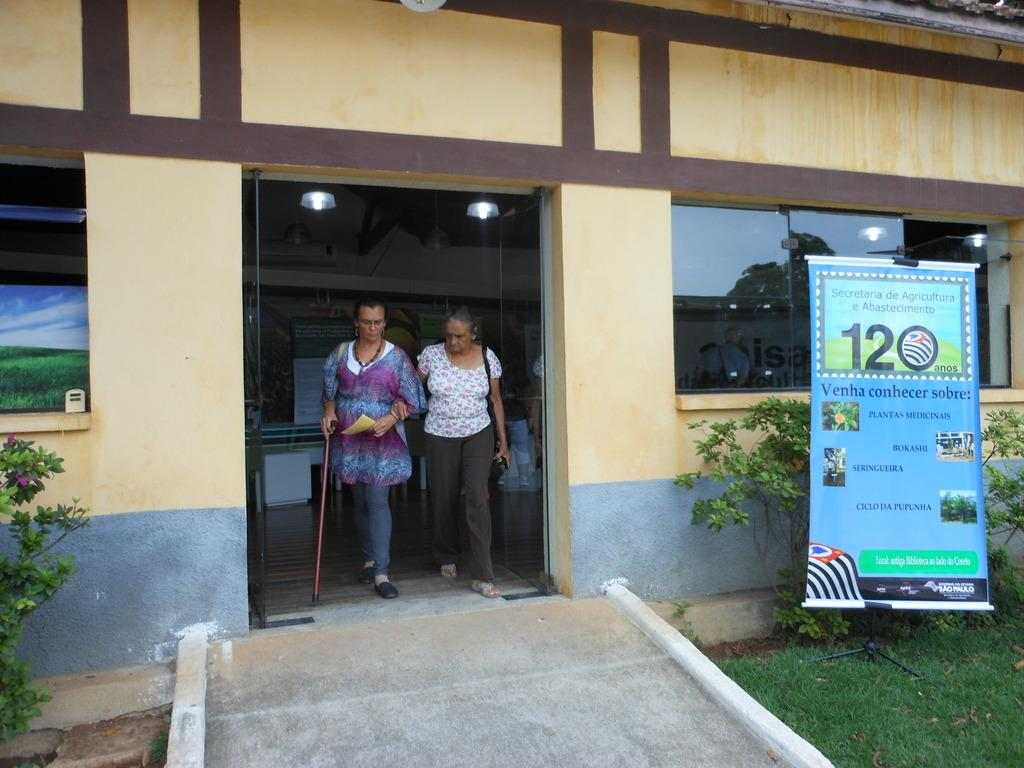How many people are walking in the image? There are two persons walking in the image. What surface are they walking on? They are walking on a path. What else can be seen in the image besides the people walking? There is a banner, plants, grass, a building with windows, and the floor visible in the image. Can you describe the building in the image? The building has windows and lights. What type of vegetation is present in the image? There are plants and grass in the image. What type of cakes are being served in the image? There is no mention of cakes in the image; it features two people walking on a path, a banner, plants, grass, a building with windows, and the floor. What is causing the throat discomfort in the image? There is no mention of throat discomfort or any medical issues in the image. 